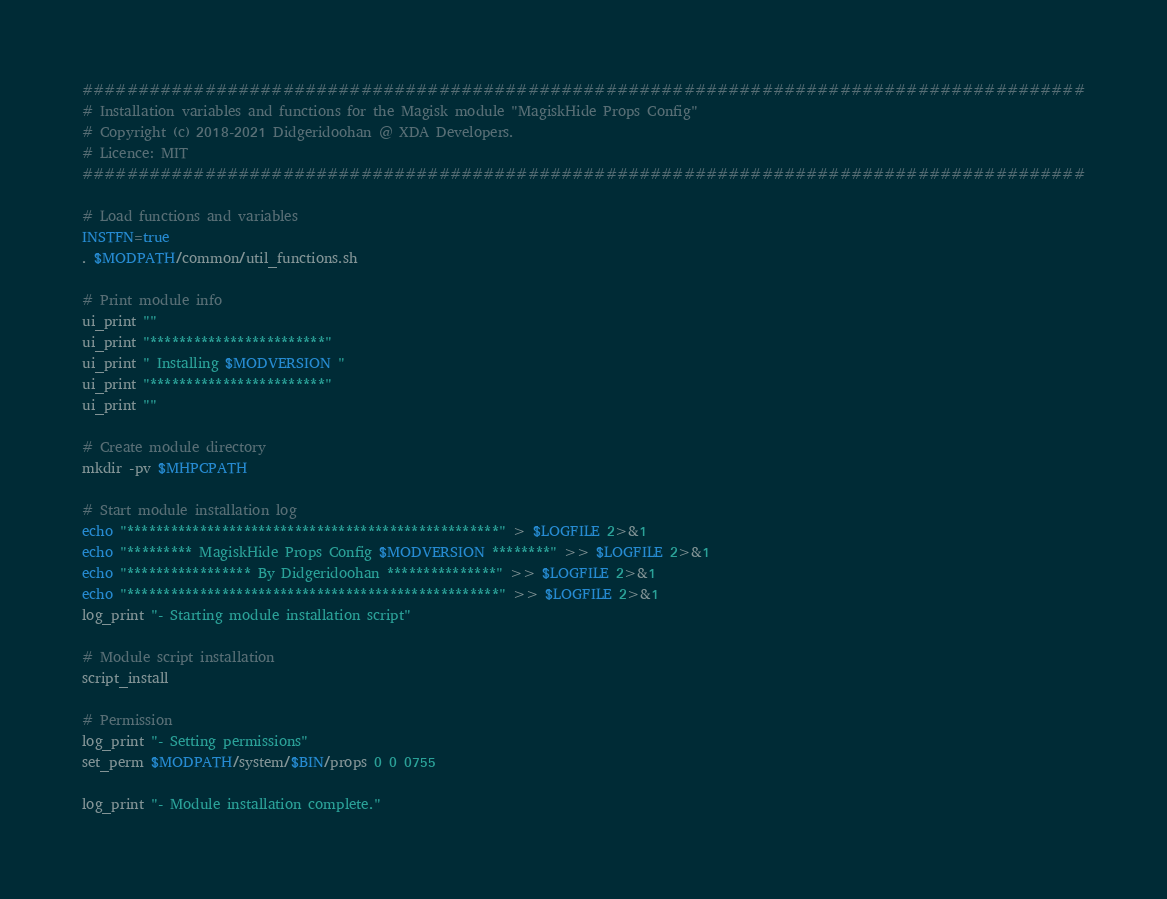<code> <loc_0><loc_0><loc_500><loc_500><_Bash_>##########################################################################################
# Installation variables and functions for the Magisk module "MagiskHide Props Config"
# Copyright (c) 2018-2021 Didgeridoohan @ XDA Developers.
# Licence: MIT
##########################################################################################

# Load functions and variables
INSTFN=true
. $MODPATH/common/util_functions.sh

# Print module info
ui_print ""
ui_print "************************"
ui_print " Installing $MODVERSION "
ui_print "************************"
ui_print ""

# Create module directory
mkdir -pv $MHPCPATH

# Start module installation log
echo "***************************************************" > $LOGFILE 2>&1
echo "********* MagiskHide Props Config $MODVERSION ********" >> $LOGFILE 2>&1
echo "***************** By Didgeridoohan ***************" >> $LOGFILE 2>&1
echo "***************************************************" >> $LOGFILE 2>&1
log_print "- Starting module installation script"

# Module script installation
script_install

# Permission
log_print "- Setting permissions"
set_perm $MODPATH/system/$BIN/props 0 0 0755

log_print "- Module installation complete."
</code> 